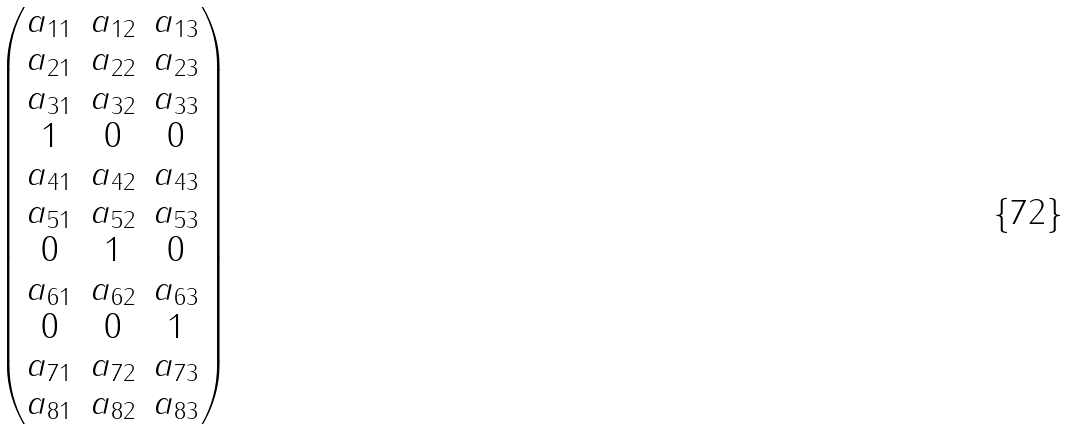Convert formula to latex. <formula><loc_0><loc_0><loc_500><loc_500>\begin{pmatrix} a _ { 1 1 } & a _ { 1 2 } & a _ { 1 3 } \\ a _ { 2 1 } & a _ { 2 2 } & a _ { 2 3 } \\ a _ { 3 1 } & a _ { 3 2 } & a _ { 3 3 } \\ 1 & 0 & 0 \\ a _ { 4 1 } & a _ { 4 2 } & a _ { 4 3 } \\ a _ { 5 1 } & a _ { 5 2 } & a _ { 5 3 } \\ 0 & 1 & 0 \\ a _ { 6 1 } & a _ { 6 2 } & a _ { 6 3 } \\ 0 & 0 & 1 \\ a _ { 7 1 } & a _ { 7 2 } & a _ { 7 3 } \\ a _ { 8 1 } & a _ { 8 2 } & a _ { 8 3 } \end{pmatrix}</formula> 